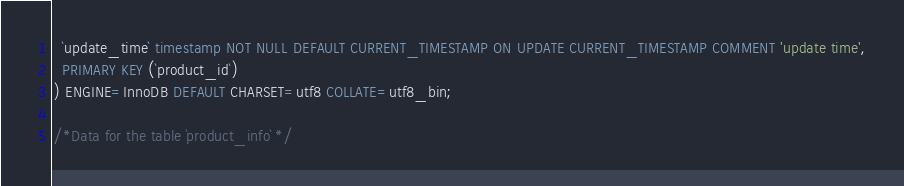Convert code to text. <code><loc_0><loc_0><loc_500><loc_500><_SQL_>  `update_time` timestamp NOT NULL DEFAULT CURRENT_TIMESTAMP ON UPDATE CURRENT_TIMESTAMP COMMENT 'update time',
  PRIMARY KEY (`product_id`)
) ENGINE=InnoDB DEFAULT CHARSET=utf8 COLLATE=utf8_bin;

/*Data for the table `product_info` */
</code> 